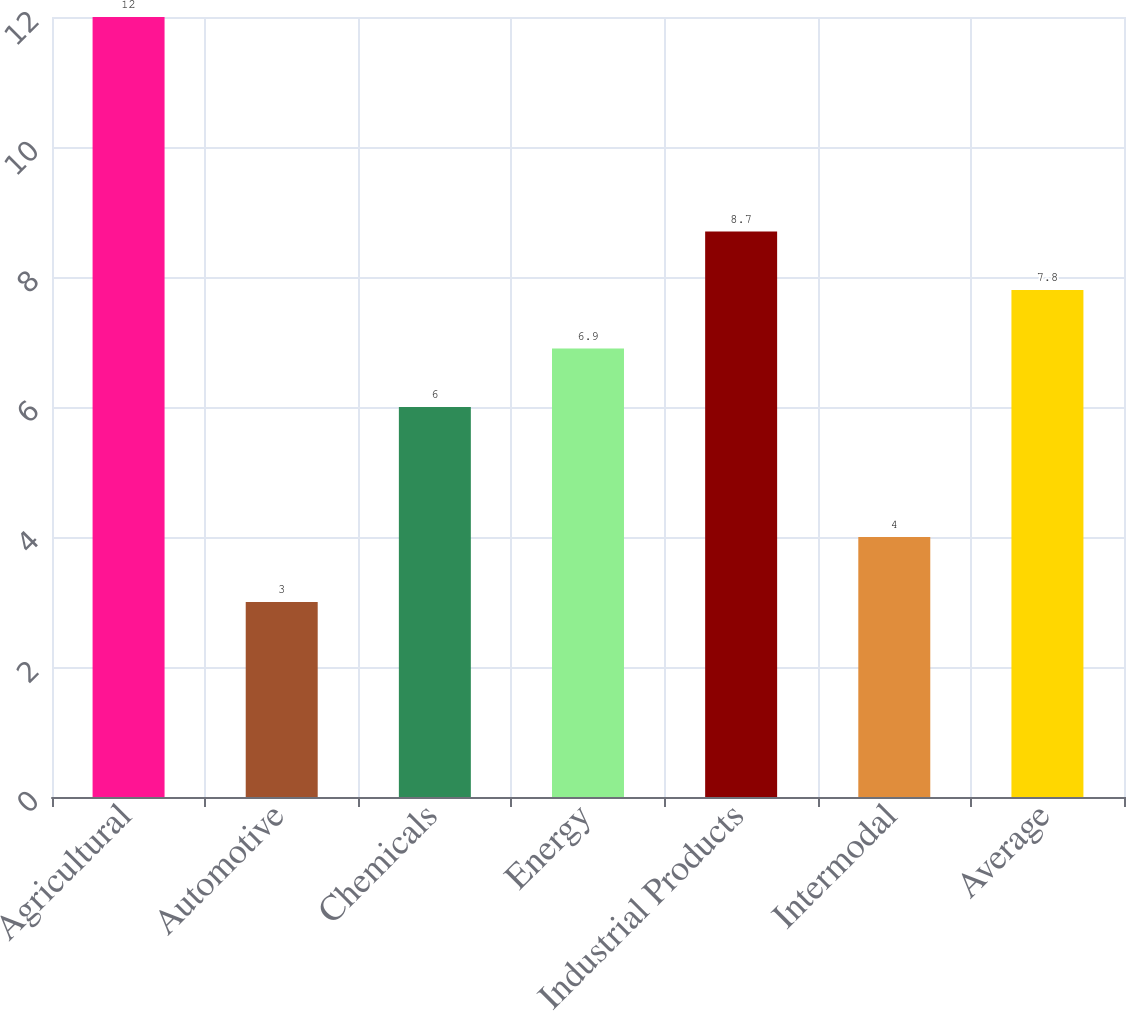Convert chart. <chart><loc_0><loc_0><loc_500><loc_500><bar_chart><fcel>Agricultural<fcel>Automotive<fcel>Chemicals<fcel>Energy<fcel>Industrial Products<fcel>Intermodal<fcel>Average<nl><fcel>12<fcel>3<fcel>6<fcel>6.9<fcel>8.7<fcel>4<fcel>7.8<nl></chart> 